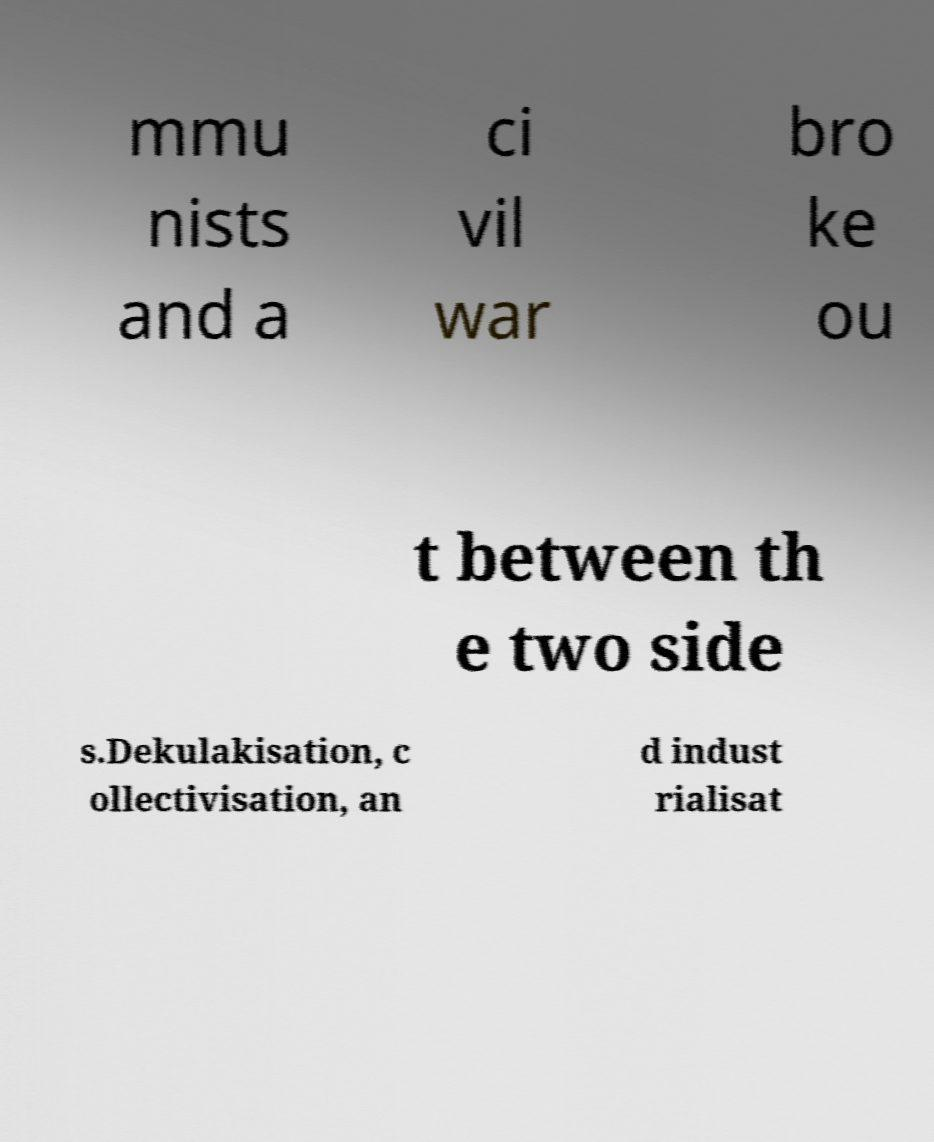Please identify and transcribe the text found in this image. mmu nists and a ci vil war bro ke ou t between th e two side s.Dekulakisation, c ollectivisation, an d indust rialisat 